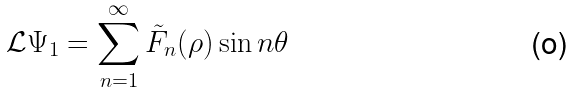<formula> <loc_0><loc_0><loc_500><loc_500>\mathcal { L } \Psi _ { 1 } = \sum _ { n = 1 } ^ { \infty } \tilde { F } _ { n } ( \rho ) \sin { n \theta }</formula> 